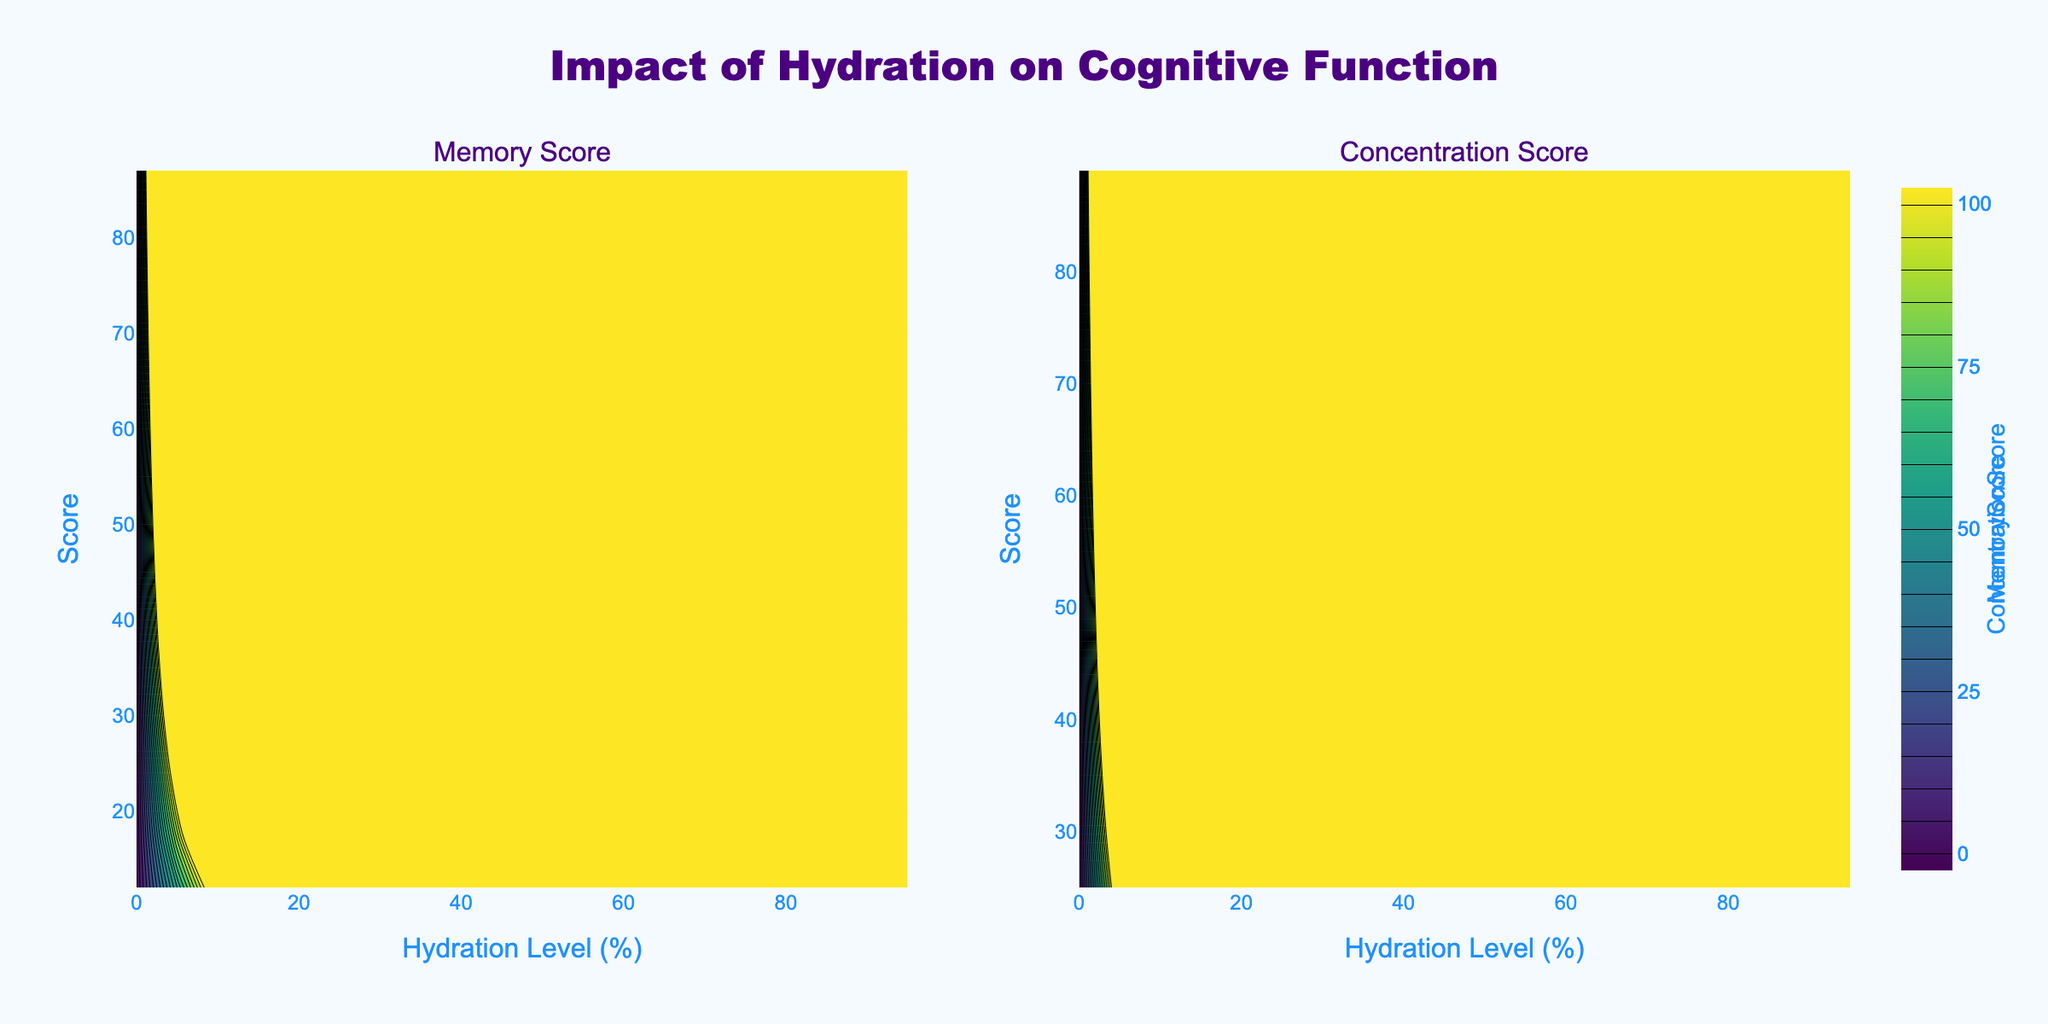How does the title of the figure relate to the content? The title of the figure is "Impact of Hydration on Cognitive Function," indicating that the figure explores how hydration levels affect memory and concentration. The two subplots show these relationships.
Answer: It relates by summarizing the exploration of the effects of hydration on memory and concentration What are the colors used in the contours and what do they represent? The contours use a colorscale called 'Viridis,' which represents different score levels with varying shades from blue to yellow. Blue likely represents lower scores, while yellow represents higher scores.
Answer: Blue to yellow, indicating score levels Describe the axes of the figure. What do they represent? The x-axes represent the Hydration Level in percentage, while the y-axes represent the scores (Memory Score and Concentration Score) in the respective subplots.
Answer: Hydration Level (%) on x, Scores on y Which subplot shows the Memory Score? The left subplot shows the Memory Score, as indicated by the subplot title above it.
Answer: Left subplot How do the scores change as hydration level decreases? As hydration levels decrease, both Memory Score and Concentration Score also tend to decrease. This is evident from the darker colors (indicative of lower scores) appearing as hydration levels decrease.
Answer: Both scores decrease Compare the trend observed in Memory Score with that in Concentration Score. Both scores decrease with lower hydration levels, but the rate may differ. The Memory Score seems to decrease more steadily, while the Concentration Score shows a sharper decline at higher hydration levels.
Answer: Both decrease, Memory Score more steadily Which Hydration Level has the highest Concentration Score? The highest Concentration Score is observed at the highest Hydration Level of 95%.
Answer: 95% At what Hydration Level do both scores seem to level out around mid-range values? Both scores appear to level out around mid-range values at a Hydration Level of approximately 50%.
Answer: Around 50% Describe any patterns observed in the contour density of the Memory Score subplot. The contour density shows that higher Memory Scores are more clustered towards higher hydration levels, indicating a strong positive correlation between hydration and memory performance.
Answer: Higher scores cluster at higher hydration levels What does the colorbar indicate in the figure, and how is it useful? The colorbar indicates the range of scores for both Memory and Concentration subplots. It helps to quickly identify the score value represented by a specific color.
Answer: Range of scores, identifies values by color 